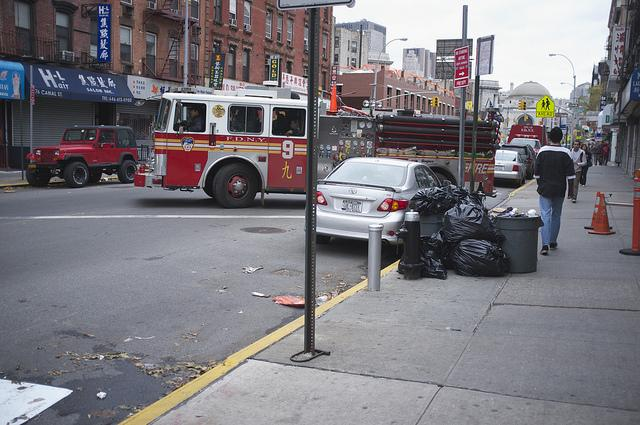For which city does this fire truck perform work? Please explain your reasoning. new york. It has fdny on the side of it 